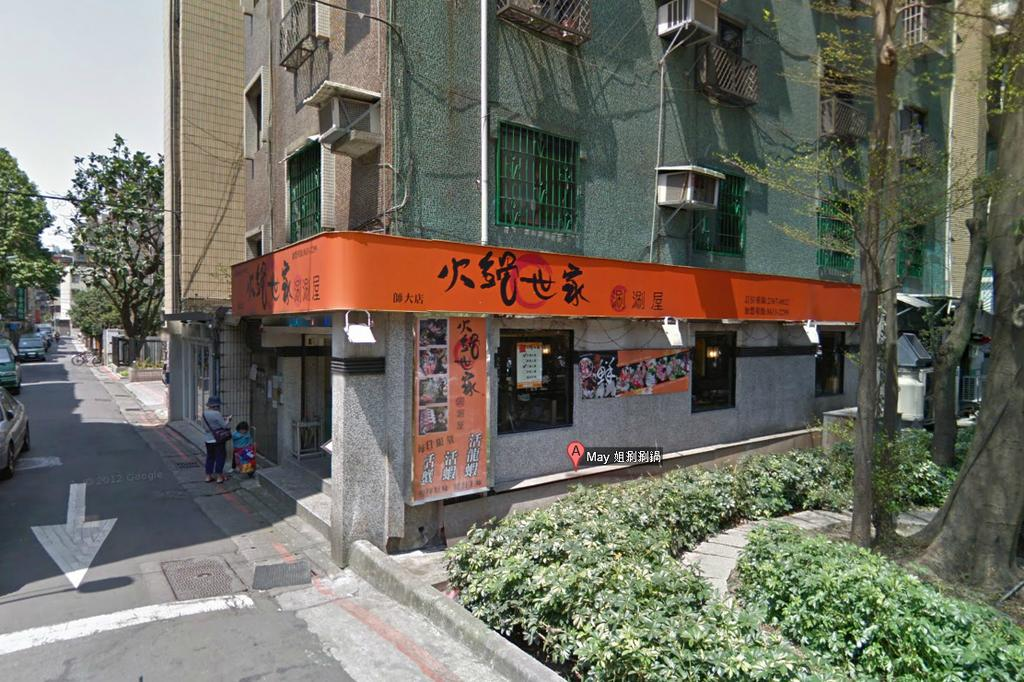What type of structures can be seen in the image? There are buildings in the image. What else can be seen in the image besides buildings? There are trees, cars on the road, two persons standing on a path, and a navigation mark with text. Can you describe the road in the image? The road has cars on it. What is the purpose of the navigation mark with text? The navigation mark with text is likely used for providing directions or information. What is visible in the sky in the image? The sky is visible in the image. What type of hen is being taught a lesson by the two persons in the image? There is no hen present in the image, and the two persons are not shown teaching or punishing anyone. 